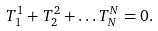Convert formula to latex. <formula><loc_0><loc_0><loc_500><loc_500>T ^ { 1 } _ { 1 } + T ^ { 2 } _ { 2 } + \dots T ^ { N } _ { N } = 0 .</formula> 